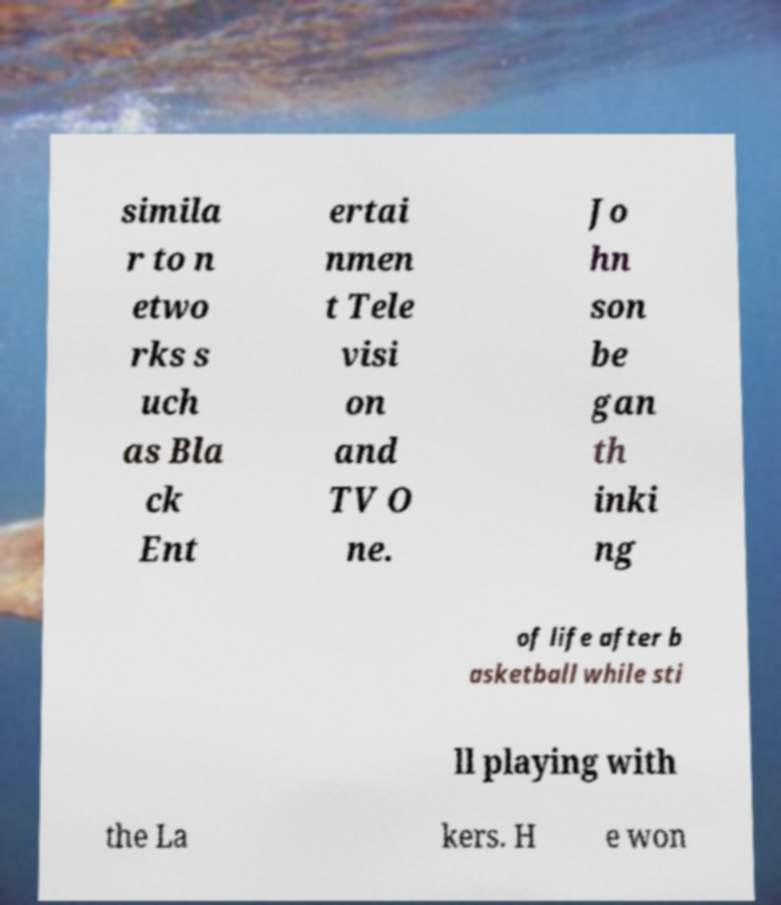Please read and relay the text visible in this image. What does it say? simila r to n etwo rks s uch as Bla ck Ent ertai nmen t Tele visi on and TV O ne. Jo hn son be gan th inki ng of life after b asketball while sti ll playing with the La kers. H e won 